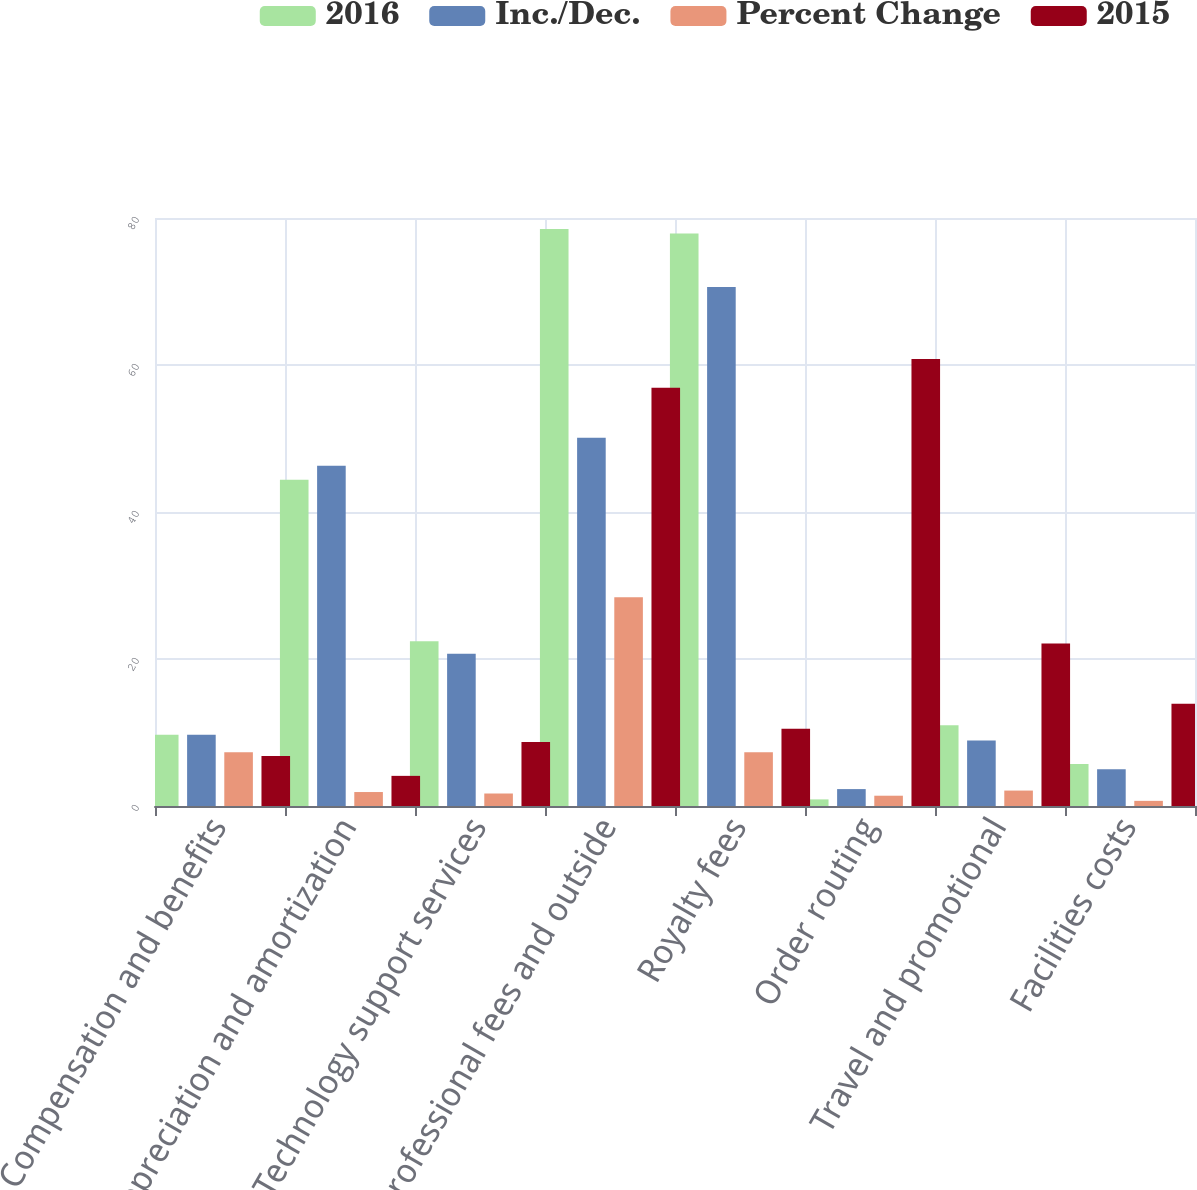Convert chart to OTSL. <chart><loc_0><loc_0><loc_500><loc_500><stacked_bar_chart><ecel><fcel>Compensation and benefits<fcel>Depreciation and amortization<fcel>Technology support services<fcel>Professional fees and outside<fcel>Royalty fees<fcel>Order routing<fcel>Travel and promotional<fcel>Facilities costs<nl><fcel>2016<fcel>9.7<fcel>44.4<fcel>22.4<fcel>78.5<fcel>77.9<fcel>0.9<fcel>11<fcel>5.7<nl><fcel>Inc./Dec.<fcel>9.7<fcel>46.3<fcel>20.7<fcel>50.1<fcel>70.6<fcel>2.3<fcel>8.9<fcel>5<nl><fcel>Percent Change<fcel>7.3<fcel>1.9<fcel>1.7<fcel>28.4<fcel>7.3<fcel>1.4<fcel>2.1<fcel>0.7<nl><fcel>2015<fcel>6.8<fcel>4.1<fcel>8.7<fcel>56.9<fcel>10.5<fcel>60.8<fcel>22.1<fcel>13.9<nl></chart> 